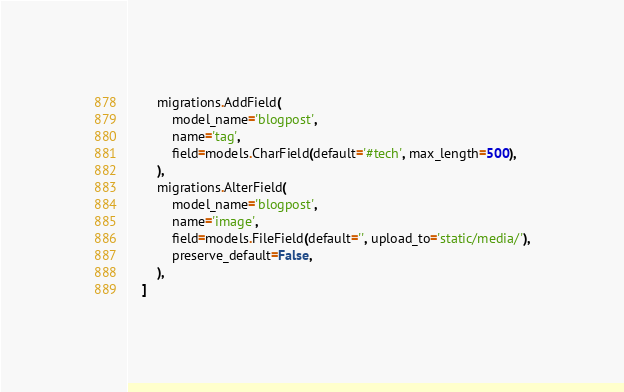<code> <loc_0><loc_0><loc_500><loc_500><_Python_>        migrations.AddField(
            model_name='blogpost',
            name='tag',
            field=models.CharField(default='#tech', max_length=500),
        ),
        migrations.AlterField(
            model_name='blogpost',
            name='image',
            field=models.FileField(default='', upload_to='static/media/'),
            preserve_default=False,
        ),
    ]
</code> 